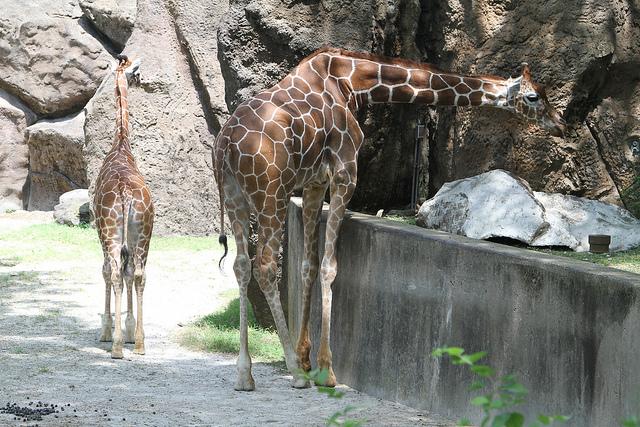How many giraffes are here?
Write a very short answer. 2. Is this animal a carnivore?
Answer briefly. No. Do these animals eat meat?
Give a very brief answer. No. Are they in a enclosed yard?
Concise answer only. Yes. 